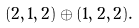<formula> <loc_0><loc_0><loc_500><loc_500>( 2 , 1 , 2 ) \oplus ( 1 , 2 , 2 ) .</formula> 